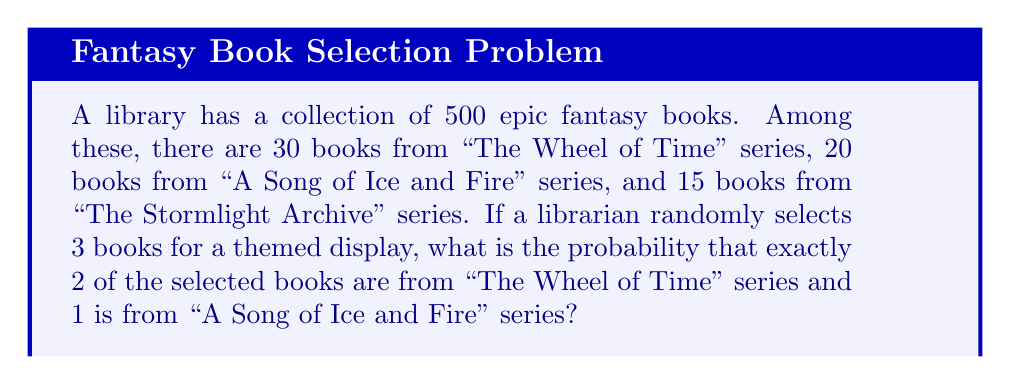Show me your answer to this math problem. Let's approach this step-by-step:

1) First, we need to calculate the total number of ways to select 3 books from 500. This is given by the combination formula:

   $$\binom{500}{3} = \frac{500!}{3!(500-3)!} = 20,708,500$$

2) Now, we need to calculate the number of ways to select 2 books from "The Wheel of Time" series (30 books), 1 book from "A Song of Ice and Fire" series (20 books), and 0 books from the rest:

   $$\binom{30}{2} \cdot \binom{20}{1} \cdot \binom{450}{0} = 435 \cdot 20 \cdot 1 = 8,700$$

3) The probability is then the number of favorable outcomes divided by the total number of possible outcomes:

   $$P(\text{2 WoT, 1 ASoIaF}) = \frac{8,700}{20,708,500} = \frac{87}{207,085} \approx 0.00042$$

4) To express this as a percentage, we multiply by 100:

   $$0.00042 \cdot 100 \approx 0.042\%$$
Answer: $\frac{87}{207,085}$ or approximately $0.042\%$ 